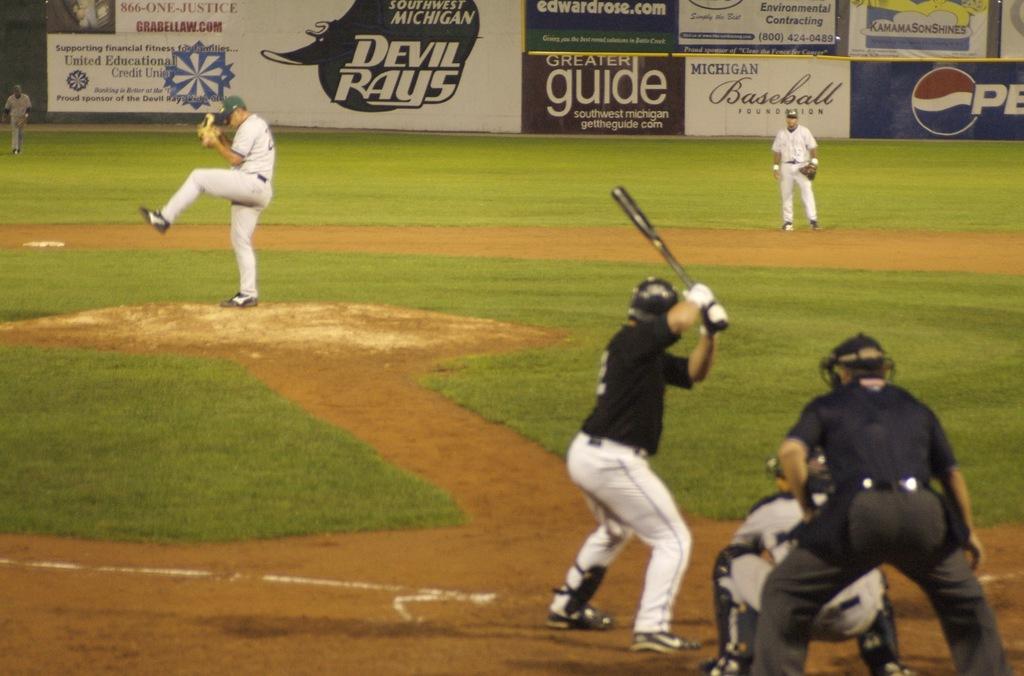Where are the devil rays from?
Your answer should be very brief. Southwest michigan. 